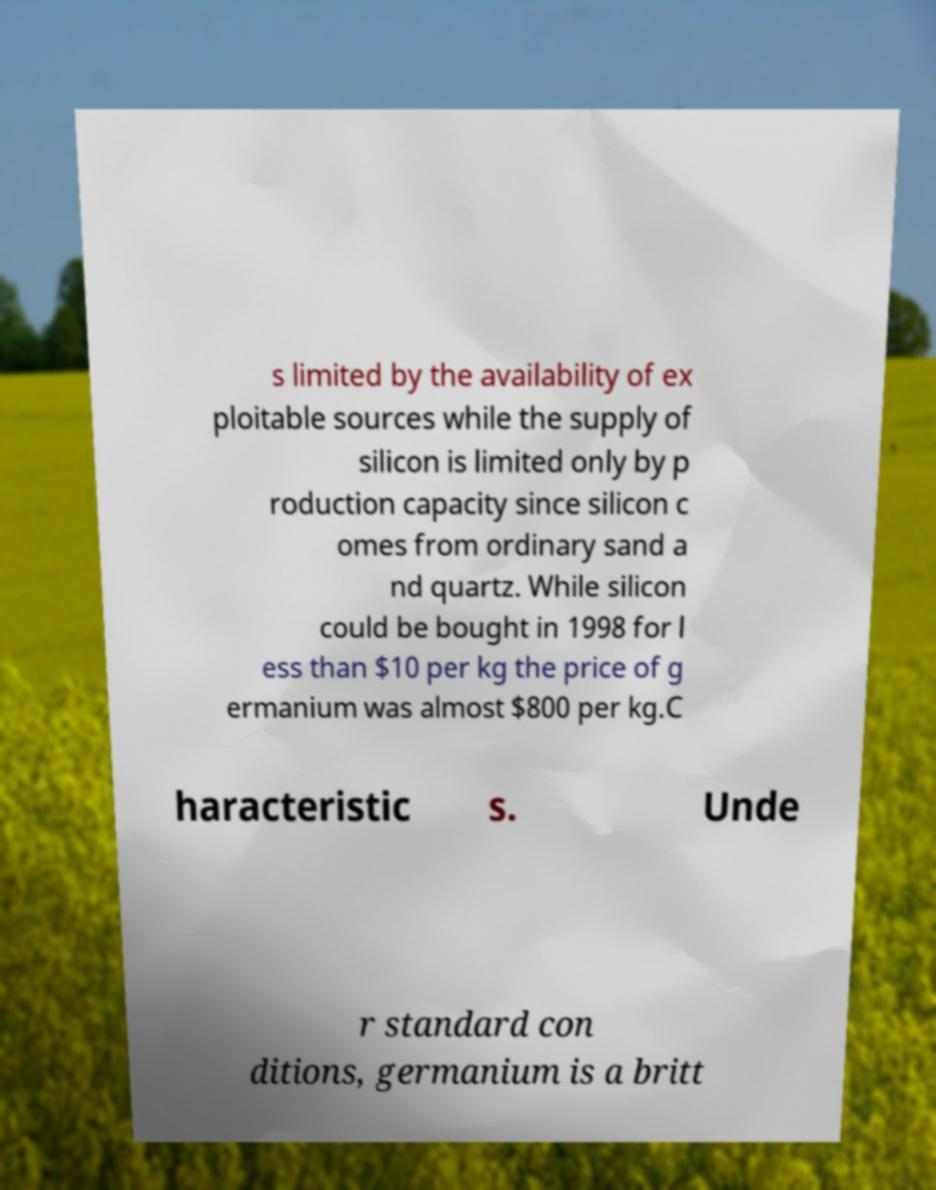What messages or text are displayed in this image? I need them in a readable, typed format. s limited by the availability of ex ploitable sources while the supply of silicon is limited only by p roduction capacity since silicon c omes from ordinary sand a nd quartz. While silicon could be bought in 1998 for l ess than $10 per kg the price of g ermanium was almost $800 per kg.C haracteristic s. Unde r standard con ditions, germanium is a britt 